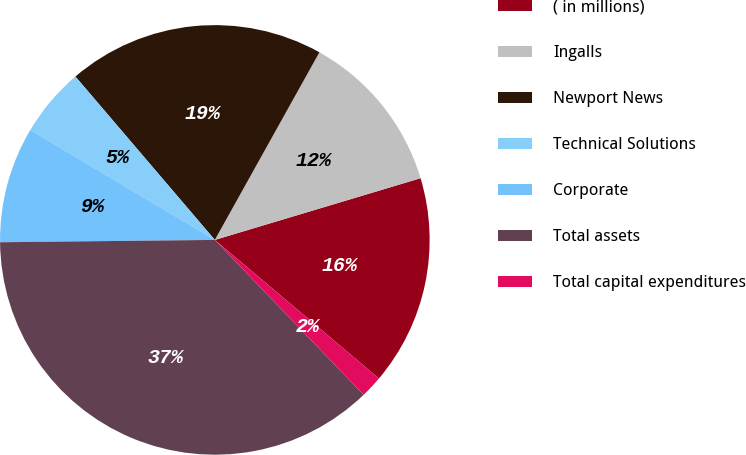<chart> <loc_0><loc_0><loc_500><loc_500><pie_chart><fcel>( in millions)<fcel>Ingalls<fcel>Newport News<fcel>Technical Solutions<fcel>Corporate<fcel>Total assets<fcel>Total capital expenditures<nl><fcel>15.8%<fcel>12.27%<fcel>19.34%<fcel>5.2%<fcel>8.73%<fcel>37.01%<fcel>1.66%<nl></chart> 